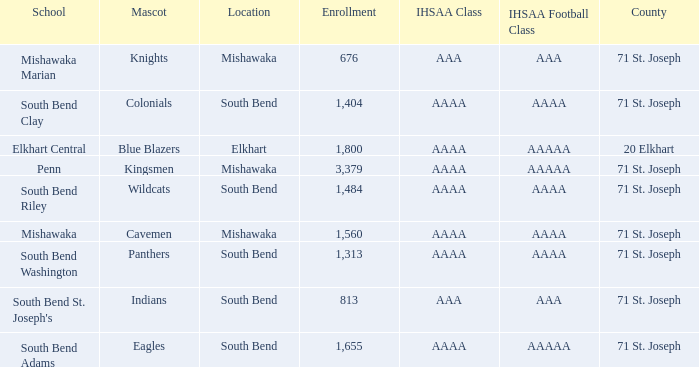Write the full table. {'header': ['School', 'Mascot', 'Location', 'Enrollment', 'IHSAA Class', 'IHSAA Football Class', 'County'], 'rows': [['Mishawaka Marian', 'Knights', 'Mishawaka', '676', 'AAA', 'AAA', '71 St. Joseph'], ['South Bend Clay', 'Colonials', 'South Bend', '1,404', 'AAAA', 'AAAA', '71 St. Joseph'], ['Elkhart Central', 'Blue Blazers', 'Elkhart', '1,800', 'AAAA', 'AAAAA', '20 Elkhart'], ['Penn', 'Kingsmen', 'Mishawaka', '3,379', 'AAAA', 'AAAAA', '71 St. Joseph'], ['South Bend Riley', 'Wildcats', 'South Bend', '1,484', 'AAAA', 'AAAA', '71 St. Joseph'], ['Mishawaka', 'Cavemen', 'Mishawaka', '1,560', 'AAAA', 'AAAA', '71 St. Joseph'], ['South Bend Washington', 'Panthers', 'South Bend', '1,313', 'AAAA', 'AAAA', '71 St. Joseph'], ["South Bend St. Joseph's", 'Indians', 'South Bend', '813', 'AAA', 'AAA', '71 St. Joseph'], ['South Bend Adams', 'Eagles', 'South Bend', '1,655', 'AAAA', 'AAAAA', '71 St. Joseph']]} What location has kingsmen as the mascot? Mishawaka. 